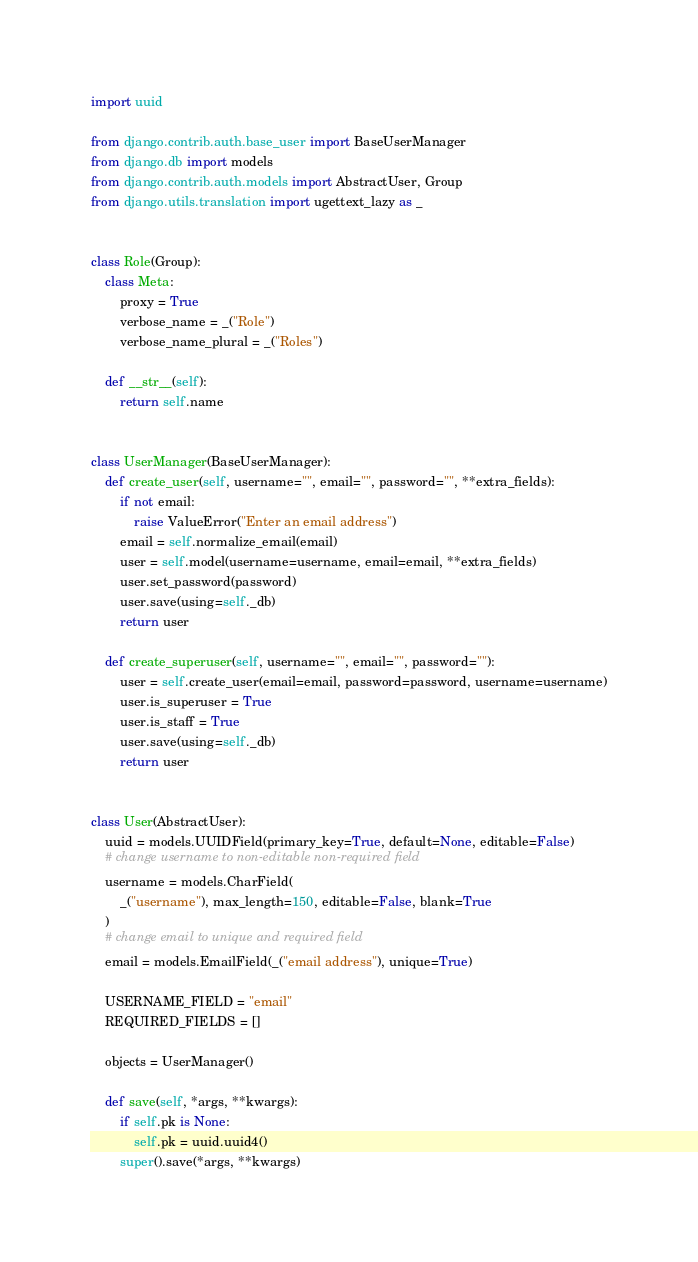Convert code to text. <code><loc_0><loc_0><loc_500><loc_500><_Python_>import uuid

from django.contrib.auth.base_user import BaseUserManager
from django.db import models
from django.contrib.auth.models import AbstractUser, Group
from django.utils.translation import ugettext_lazy as _


class Role(Group):
    class Meta:
        proxy = True
        verbose_name = _("Role")
        verbose_name_plural = _("Roles")

    def __str__(self):
        return self.name


class UserManager(BaseUserManager):
    def create_user(self, username="", email="", password="", **extra_fields):
        if not email:
            raise ValueError("Enter an email address")
        email = self.normalize_email(email)
        user = self.model(username=username, email=email, **extra_fields)
        user.set_password(password)
        user.save(using=self._db)
        return user

    def create_superuser(self, username="", email="", password=""):
        user = self.create_user(email=email, password=password, username=username)
        user.is_superuser = True
        user.is_staff = True
        user.save(using=self._db)
        return user


class User(AbstractUser):
    uuid = models.UUIDField(primary_key=True, default=None, editable=False)
    # change username to non-editable non-required field
    username = models.CharField(
        _("username"), max_length=150, editable=False, blank=True
    )
    # change email to unique and required field
    email = models.EmailField(_("email address"), unique=True)

    USERNAME_FIELD = "email"
    REQUIRED_FIELDS = []

    objects = UserManager()

    def save(self, *args, **kwargs):
        if self.pk is None:
            self.pk = uuid.uuid4()
        super().save(*args, **kwargs)
</code> 